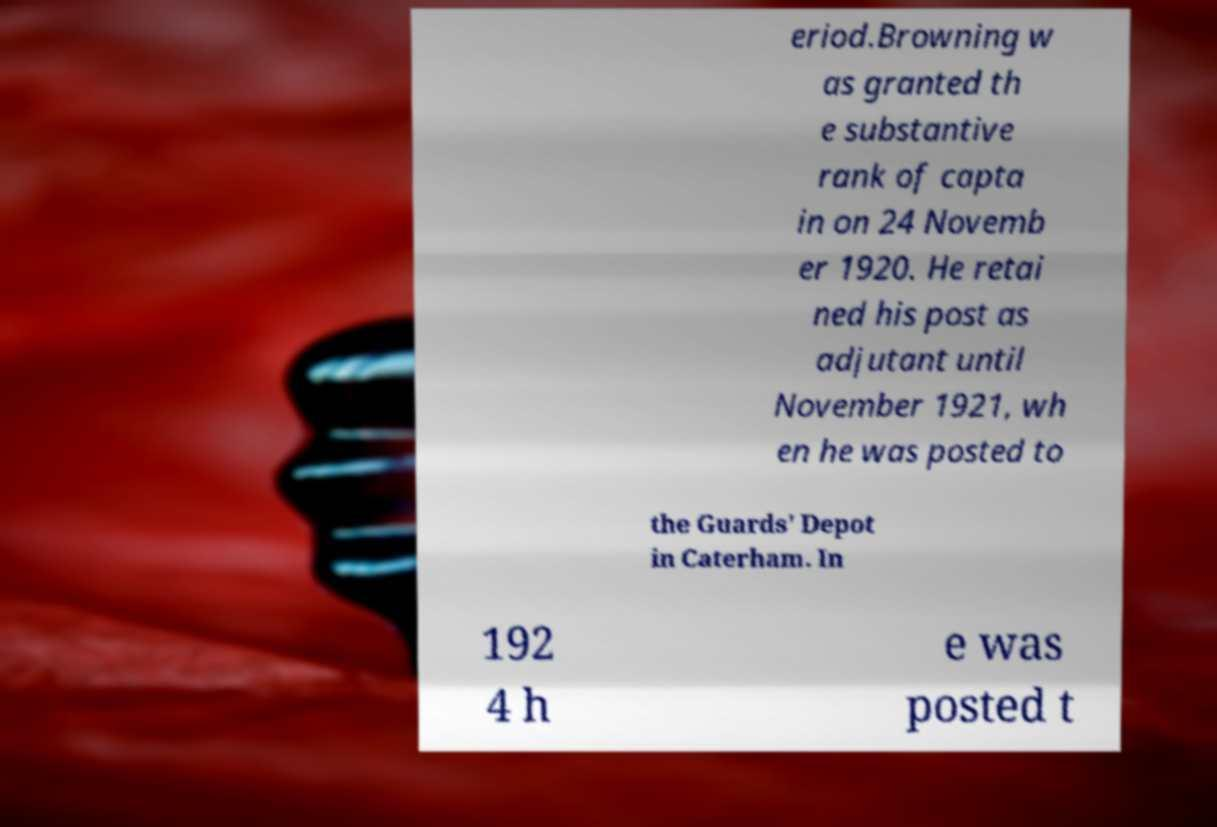Please identify and transcribe the text found in this image. eriod.Browning w as granted th e substantive rank of capta in on 24 Novemb er 1920. He retai ned his post as adjutant until November 1921, wh en he was posted to the Guards' Depot in Caterham. In 192 4 h e was posted t 